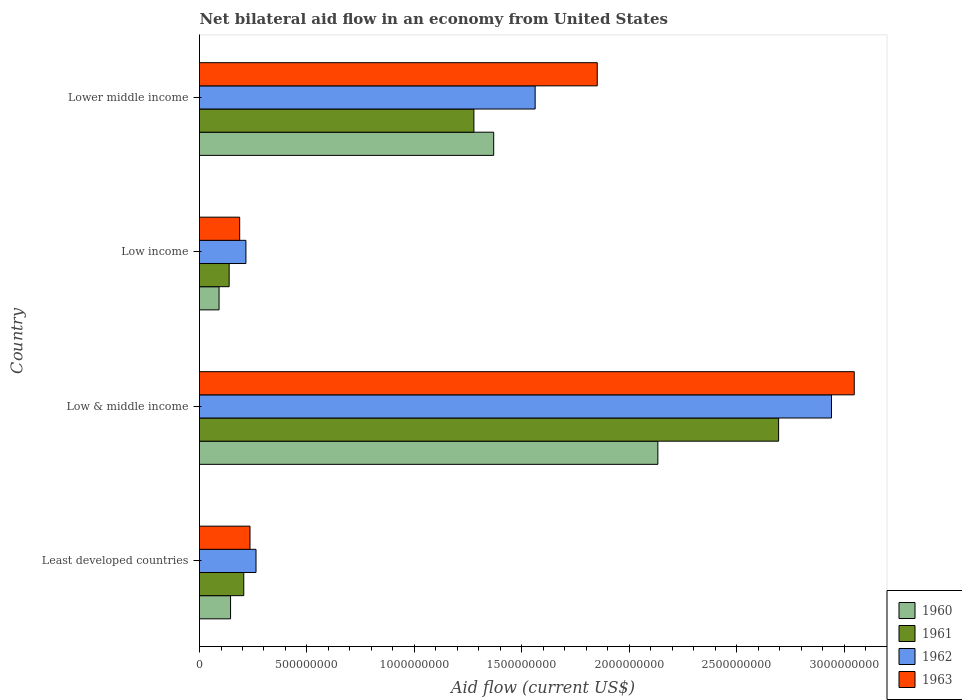How many different coloured bars are there?
Your response must be concise. 4. How many groups of bars are there?
Offer a terse response. 4. Are the number of bars per tick equal to the number of legend labels?
Provide a succinct answer. Yes. How many bars are there on the 2nd tick from the top?
Give a very brief answer. 4. How many bars are there on the 1st tick from the bottom?
Your answer should be compact. 4. What is the label of the 1st group of bars from the top?
Give a very brief answer. Lower middle income. In how many cases, is the number of bars for a given country not equal to the number of legend labels?
Offer a very short reply. 0. What is the net bilateral aid flow in 1960 in Low & middle income?
Provide a succinct answer. 2.13e+09. Across all countries, what is the maximum net bilateral aid flow in 1960?
Give a very brief answer. 2.13e+09. Across all countries, what is the minimum net bilateral aid flow in 1960?
Offer a very short reply. 9.10e+07. What is the total net bilateral aid flow in 1962 in the graph?
Your answer should be compact. 4.98e+09. What is the difference between the net bilateral aid flow in 1963 in Least developed countries and that in Lower middle income?
Give a very brief answer. -1.62e+09. What is the difference between the net bilateral aid flow in 1961 in Lower middle income and the net bilateral aid flow in 1960 in Low income?
Keep it short and to the point. 1.19e+09. What is the average net bilateral aid flow in 1960 per country?
Provide a succinct answer. 9.34e+08. What is the difference between the net bilateral aid flow in 1961 and net bilateral aid flow in 1960 in Least developed countries?
Give a very brief answer. 6.15e+07. What is the ratio of the net bilateral aid flow in 1961 in Least developed countries to that in Low & middle income?
Give a very brief answer. 0.08. What is the difference between the highest and the second highest net bilateral aid flow in 1961?
Provide a short and direct response. 1.42e+09. What is the difference between the highest and the lowest net bilateral aid flow in 1961?
Your answer should be compact. 2.56e+09. Is the sum of the net bilateral aid flow in 1962 in Least developed countries and Low & middle income greater than the maximum net bilateral aid flow in 1961 across all countries?
Offer a terse response. Yes. What does the 1st bar from the top in Low & middle income represents?
Offer a terse response. 1963. What does the 4th bar from the bottom in Lower middle income represents?
Keep it short and to the point. 1963. How many countries are there in the graph?
Offer a terse response. 4. Does the graph contain any zero values?
Give a very brief answer. No. Does the graph contain grids?
Offer a terse response. No. Where does the legend appear in the graph?
Keep it short and to the point. Bottom right. What is the title of the graph?
Your answer should be compact. Net bilateral aid flow in an economy from United States. Does "1976" appear as one of the legend labels in the graph?
Your response must be concise. No. What is the label or title of the Y-axis?
Offer a very short reply. Country. What is the Aid flow (current US$) of 1960 in Least developed countries?
Provide a succinct answer. 1.45e+08. What is the Aid flow (current US$) of 1961 in Least developed countries?
Offer a terse response. 2.06e+08. What is the Aid flow (current US$) of 1962 in Least developed countries?
Provide a succinct answer. 2.63e+08. What is the Aid flow (current US$) in 1963 in Least developed countries?
Provide a short and direct response. 2.35e+08. What is the Aid flow (current US$) in 1960 in Low & middle income?
Provide a succinct answer. 2.13e+09. What is the Aid flow (current US$) in 1961 in Low & middle income?
Offer a very short reply. 2.70e+09. What is the Aid flow (current US$) of 1962 in Low & middle income?
Make the answer very short. 2.94e+09. What is the Aid flow (current US$) of 1963 in Low & middle income?
Make the answer very short. 3.05e+09. What is the Aid flow (current US$) of 1960 in Low income?
Keep it short and to the point. 9.10e+07. What is the Aid flow (current US$) in 1961 in Low income?
Your answer should be compact. 1.38e+08. What is the Aid flow (current US$) of 1962 in Low income?
Ensure brevity in your answer.  2.16e+08. What is the Aid flow (current US$) of 1963 in Low income?
Provide a short and direct response. 1.87e+08. What is the Aid flow (current US$) in 1960 in Lower middle income?
Offer a terse response. 1.37e+09. What is the Aid flow (current US$) in 1961 in Lower middle income?
Give a very brief answer. 1.28e+09. What is the Aid flow (current US$) of 1962 in Lower middle income?
Your answer should be compact. 1.56e+09. What is the Aid flow (current US$) in 1963 in Lower middle income?
Provide a succinct answer. 1.85e+09. Across all countries, what is the maximum Aid flow (current US$) of 1960?
Your response must be concise. 2.13e+09. Across all countries, what is the maximum Aid flow (current US$) of 1961?
Offer a very short reply. 2.70e+09. Across all countries, what is the maximum Aid flow (current US$) in 1962?
Provide a succinct answer. 2.94e+09. Across all countries, what is the maximum Aid flow (current US$) in 1963?
Your answer should be very brief. 3.05e+09. Across all countries, what is the minimum Aid flow (current US$) of 1960?
Keep it short and to the point. 9.10e+07. Across all countries, what is the minimum Aid flow (current US$) of 1961?
Keep it short and to the point. 1.38e+08. Across all countries, what is the minimum Aid flow (current US$) in 1962?
Give a very brief answer. 2.16e+08. Across all countries, what is the minimum Aid flow (current US$) in 1963?
Your answer should be compact. 1.87e+08. What is the total Aid flow (current US$) in 1960 in the graph?
Provide a succinct answer. 3.74e+09. What is the total Aid flow (current US$) of 1961 in the graph?
Your answer should be compact. 4.32e+09. What is the total Aid flow (current US$) of 1962 in the graph?
Provide a succinct answer. 4.98e+09. What is the total Aid flow (current US$) in 1963 in the graph?
Your answer should be very brief. 5.32e+09. What is the difference between the Aid flow (current US$) of 1960 in Least developed countries and that in Low & middle income?
Your answer should be very brief. -1.99e+09. What is the difference between the Aid flow (current US$) in 1961 in Least developed countries and that in Low & middle income?
Offer a terse response. -2.49e+09. What is the difference between the Aid flow (current US$) in 1962 in Least developed countries and that in Low & middle income?
Offer a very short reply. -2.68e+09. What is the difference between the Aid flow (current US$) of 1963 in Least developed countries and that in Low & middle income?
Provide a succinct answer. -2.81e+09. What is the difference between the Aid flow (current US$) in 1960 in Least developed countries and that in Low income?
Your answer should be compact. 5.35e+07. What is the difference between the Aid flow (current US$) of 1961 in Least developed countries and that in Low income?
Your answer should be very brief. 6.80e+07. What is the difference between the Aid flow (current US$) in 1962 in Least developed countries and that in Low income?
Your answer should be compact. 4.70e+07. What is the difference between the Aid flow (current US$) of 1963 in Least developed countries and that in Low income?
Provide a short and direct response. 4.80e+07. What is the difference between the Aid flow (current US$) of 1960 in Least developed countries and that in Lower middle income?
Ensure brevity in your answer.  -1.22e+09. What is the difference between the Aid flow (current US$) in 1961 in Least developed countries and that in Lower middle income?
Offer a terse response. -1.07e+09. What is the difference between the Aid flow (current US$) in 1962 in Least developed countries and that in Lower middle income?
Your answer should be very brief. -1.30e+09. What is the difference between the Aid flow (current US$) in 1963 in Least developed countries and that in Lower middle income?
Give a very brief answer. -1.62e+09. What is the difference between the Aid flow (current US$) in 1960 in Low & middle income and that in Low income?
Ensure brevity in your answer.  2.04e+09. What is the difference between the Aid flow (current US$) in 1961 in Low & middle income and that in Low income?
Your answer should be very brief. 2.56e+09. What is the difference between the Aid flow (current US$) of 1962 in Low & middle income and that in Low income?
Your answer should be very brief. 2.72e+09. What is the difference between the Aid flow (current US$) in 1963 in Low & middle income and that in Low income?
Offer a very short reply. 2.86e+09. What is the difference between the Aid flow (current US$) in 1960 in Low & middle income and that in Lower middle income?
Your answer should be very brief. 7.64e+08. What is the difference between the Aid flow (current US$) in 1961 in Low & middle income and that in Lower middle income?
Your response must be concise. 1.42e+09. What is the difference between the Aid flow (current US$) in 1962 in Low & middle income and that in Lower middle income?
Offer a terse response. 1.38e+09. What is the difference between the Aid flow (current US$) in 1963 in Low & middle income and that in Lower middle income?
Keep it short and to the point. 1.20e+09. What is the difference between the Aid flow (current US$) of 1960 in Low income and that in Lower middle income?
Offer a very short reply. -1.28e+09. What is the difference between the Aid flow (current US$) in 1961 in Low income and that in Lower middle income?
Offer a very short reply. -1.14e+09. What is the difference between the Aid flow (current US$) in 1962 in Low income and that in Lower middle income?
Offer a very short reply. -1.35e+09. What is the difference between the Aid flow (current US$) in 1963 in Low income and that in Lower middle income?
Provide a short and direct response. -1.66e+09. What is the difference between the Aid flow (current US$) in 1960 in Least developed countries and the Aid flow (current US$) in 1961 in Low & middle income?
Offer a very short reply. -2.55e+09. What is the difference between the Aid flow (current US$) of 1960 in Least developed countries and the Aid flow (current US$) of 1962 in Low & middle income?
Your answer should be compact. -2.80e+09. What is the difference between the Aid flow (current US$) in 1960 in Least developed countries and the Aid flow (current US$) in 1963 in Low & middle income?
Keep it short and to the point. -2.90e+09. What is the difference between the Aid flow (current US$) in 1961 in Least developed countries and the Aid flow (current US$) in 1962 in Low & middle income?
Your answer should be very brief. -2.74e+09. What is the difference between the Aid flow (current US$) of 1961 in Least developed countries and the Aid flow (current US$) of 1963 in Low & middle income?
Your response must be concise. -2.84e+09. What is the difference between the Aid flow (current US$) in 1962 in Least developed countries and the Aid flow (current US$) in 1963 in Low & middle income?
Keep it short and to the point. -2.78e+09. What is the difference between the Aid flow (current US$) in 1960 in Least developed countries and the Aid flow (current US$) in 1961 in Low income?
Provide a succinct answer. 6.52e+06. What is the difference between the Aid flow (current US$) of 1960 in Least developed countries and the Aid flow (current US$) of 1962 in Low income?
Offer a very short reply. -7.15e+07. What is the difference between the Aid flow (current US$) of 1960 in Least developed countries and the Aid flow (current US$) of 1963 in Low income?
Provide a short and direct response. -4.25e+07. What is the difference between the Aid flow (current US$) of 1961 in Least developed countries and the Aid flow (current US$) of 1962 in Low income?
Your response must be concise. -1.00e+07. What is the difference between the Aid flow (current US$) of 1961 in Least developed countries and the Aid flow (current US$) of 1963 in Low income?
Make the answer very short. 1.90e+07. What is the difference between the Aid flow (current US$) in 1962 in Least developed countries and the Aid flow (current US$) in 1963 in Low income?
Your answer should be very brief. 7.60e+07. What is the difference between the Aid flow (current US$) of 1960 in Least developed countries and the Aid flow (current US$) of 1961 in Lower middle income?
Offer a terse response. -1.13e+09. What is the difference between the Aid flow (current US$) in 1960 in Least developed countries and the Aid flow (current US$) in 1962 in Lower middle income?
Give a very brief answer. -1.42e+09. What is the difference between the Aid flow (current US$) in 1960 in Least developed countries and the Aid flow (current US$) in 1963 in Lower middle income?
Give a very brief answer. -1.71e+09. What is the difference between the Aid flow (current US$) of 1961 in Least developed countries and the Aid flow (current US$) of 1962 in Lower middle income?
Give a very brief answer. -1.36e+09. What is the difference between the Aid flow (current US$) of 1961 in Least developed countries and the Aid flow (current US$) of 1963 in Lower middle income?
Ensure brevity in your answer.  -1.64e+09. What is the difference between the Aid flow (current US$) in 1962 in Least developed countries and the Aid flow (current US$) in 1963 in Lower middle income?
Offer a very short reply. -1.59e+09. What is the difference between the Aid flow (current US$) of 1960 in Low & middle income and the Aid flow (current US$) of 1961 in Low income?
Provide a succinct answer. 2.00e+09. What is the difference between the Aid flow (current US$) of 1960 in Low & middle income and the Aid flow (current US$) of 1962 in Low income?
Ensure brevity in your answer.  1.92e+09. What is the difference between the Aid flow (current US$) of 1960 in Low & middle income and the Aid flow (current US$) of 1963 in Low income?
Ensure brevity in your answer.  1.95e+09. What is the difference between the Aid flow (current US$) in 1961 in Low & middle income and the Aid flow (current US$) in 1962 in Low income?
Make the answer very short. 2.48e+09. What is the difference between the Aid flow (current US$) in 1961 in Low & middle income and the Aid flow (current US$) in 1963 in Low income?
Provide a succinct answer. 2.51e+09. What is the difference between the Aid flow (current US$) of 1962 in Low & middle income and the Aid flow (current US$) of 1963 in Low income?
Give a very brief answer. 2.75e+09. What is the difference between the Aid flow (current US$) of 1960 in Low & middle income and the Aid flow (current US$) of 1961 in Lower middle income?
Make the answer very short. 8.56e+08. What is the difference between the Aid flow (current US$) in 1960 in Low & middle income and the Aid flow (current US$) in 1962 in Lower middle income?
Your response must be concise. 5.71e+08. What is the difference between the Aid flow (current US$) of 1960 in Low & middle income and the Aid flow (current US$) of 1963 in Lower middle income?
Your response must be concise. 2.82e+08. What is the difference between the Aid flow (current US$) of 1961 in Low & middle income and the Aid flow (current US$) of 1962 in Lower middle income?
Provide a succinct answer. 1.13e+09. What is the difference between the Aid flow (current US$) of 1961 in Low & middle income and the Aid flow (current US$) of 1963 in Lower middle income?
Offer a terse response. 8.44e+08. What is the difference between the Aid flow (current US$) in 1962 in Low & middle income and the Aid flow (current US$) in 1963 in Lower middle income?
Your answer should be very brief. 1.09e+09. What is the difference between the Aid flow (current US$) in 1960 in Low income and the Aid flow (current US$) in 1961 in Lower middle income?
Provide a short and direct response. -1.19e+09. What is the difference between the Aid flow (current US$) in 1960 in Low income and the Aid flow (current US$) in 1962 in Lower middle income?
Your response must be concise. -1.47e+09. What is the difference between the Aid flow (current US$) of 1960 in Low income and the Aid flow (current US$) of 1963 in Lower middle income?
Make the answer very short. -1.76e+09. What is the difference between the Aid flow (current US$) of 1961 in Low income and the Aid flow (current US$) of 1962 in Lower middle income?
Provide a succinct answer. -1.42e+09. What is the difference between the Aid flow (current US$) of 1961 in Low income and the Aid flow (current US$) of 1963 in Lower middle income?
Your response must be concise. -1.71e+09. What is the difference between the Aid flow (current US$) in 1962 in Low income and the Aid flow (current US$) in 1963 in Lower middle income?
Make the answer very short. -1.64e+09. What is the average Aid flow (current US$) of 1960 per country?
Provide a succinct answer. 9.34e+08. What is the average Aid flow (current US$) of 1961 per country?
Make the answer very short. 1.08e+09. What is the average Aid flow (current US$) in 1962 per country?
Your answer should be compact. 1.25e+09. What is the average Aid flow (current US$) in 1963 per country?
Your answer should be very brief. 1.33e+09. What is the difference between the Aid flow (current US$) of 1960 and Aid flow (current US$) of 1961 in Least developed countries?
Make the answer very short. -6.15e+07. What is the difference between the Aid flow (current US$) of 1960 and Aid flow (current US$) of 1962 in Least developed countries?
Provide a short and direct response. -1.18e+08. What is the difference between the Aid flow (current US$) of 1960 and Aid flow (current US$) of 1963 in Least developed countries?
Your response must be concise. -9.05e+07. What is the difference between the Aid flow (current US$) of 1961 and Aid flow (current US$) of 1962 in Least developed countries?
Give a very brief answer. -5.70e+07. What is the difference between the Aid flow (current US$) in 1961 and Aid flow (current US$) in 1963 in Least developed countries?
Give a very brief answer. -2.90e+07. What is the difference between the Aid flow (current US$) of 1962 and Aid flow (current US$) of 1963 in Least developed countries?
Provide a succinct answer. 2.80e+07. What is the difference between the Aid flow (current US$) in 1960 and Aid flow (current US$) in 1961 in Low & middle income?
Your answer should be very brief. -5.62e+08. What is the difference between the Aid flow (current US$) of 1960 and Aid flow (current US$) of 1962 in Low & middle income?
Your answer should be very brief. -8.08e+08. What is the difference between the Aid flow (current US$) of 1960 and Aid flow (current US$) of 1963 in Low & middle income?
Offer a very short reply. -9.14e+08. What is the difference between the Aid flow (current US$) of 1961 and Aid flow (current US$) of 1962 in Low & middle income?
Keep it short and to the point. -2.46e+08. What is the difference between the Aid flow (current US$) of 1961 and Aid flow (current US$) of 1963 in Low & middle income?
Your answer should be compact. -3.52e+08. What is the difference between the Aid flow (current US$) in 1962 and Aid flow (current US$) in 1963 in Low & middle income?
Keep it short and to the point. -1.06e+08. What is the difference between the Aid flow (current US$) of 1960 and Aid flow (current US$) of 1961 in Low income?
Your response must be concise. -4.70e+07. What is the difference between the Aid flow (current US$) of 1960 and Aid flow (current US$) of 1962 in Low income?
Make the answer very short. -1.25e+08. What is the difference between the Aid flow (current US$) in 1960 and Aid flow (current US$) in 1963 in Low income?
Offer a terse response. -9.60e+07. What is the difference between the Aid flow (current US$) of 1961 and Aid flow (current US$) of 1962 in Low income?
Provide a succinct answer. -7.80e+07. What is the difference between the Aid flow (current US$) in 1961 and Aid flow (current US$) in 1963 in Low income?
Make the answer very short. -4.90e+07. What is the difference between the Aid flow (current US$) in 1962 and Aid flow (current US$) in 1963 in Low income?
Your response must be concise. 2.90e+07. What is the difference between the Aid flow (current US$) of 1960 and Aid flow (current US$) of 1961 in Lower middle income?
Your answer should be compact. 9.20e+07. What is the difference between the Aid flow (current US$) of 1960 and Aid flow (current US$) of 1962 in Lower middle income?
Offer a very short reply. -1.93e+08. What is the difference between the Aid flow (current US$) of 1960 and Aid flow (current US$) of 1963 in Lower middle income?
Ensure brevity in your answer.  -4.82e+08. What is the difference between the Aid flow (current US$) of 1961 and Aid flow (current US$) of 1962 in Lower middle income?
Keep it short and to the point. -2.85e+08. What is the difference between the Aid flow (current US$) in 1961 and Aid flow (current US$) in 1963 in Lower middle income?
Your response must be concise. -5.74e+08. What is the difference between the Aid flow (current US$) of 1962 and Aid flow (current US$) of 1963 in Lower middle income?
Make the answer very short. -2.89e+08. What is the ratio of the Aid flow (current US$) of 1960 in Least developed countries to that in Low & middle income?
Ensure brevity in your answer.  0.07. What is the ratio of the Aid flow (current US$) of 1961 in Least developed countries to that in Low & middle income?
Keep it short and to the point. 0.08. What is the ratio of the Aid flow (current US$) in 1962 in Least developed countries to that in Low & middle income?
Offer a very short reply. 0.09. What is the ratio of the Aid flow (current US$) of 1963 in Least developed countries to that in Low & middle income?
Offer a terse response. 0.08. What is the ratio of the Aid flow (current US$) in 1960 in Least developed countries to that in Low income?
Your response must be concise. 1.59. What is the ratio of the Aid flow (current US$) of 1961 in Least developed countries to that in Low income?
Your response must be concise. 1.49. What is the ratio of the Aid flow (current US$) of 1962 in Least developed countries to that in Low income?
Give a very brief answer. 1.22. What is the ratio of the Aid flow (current US$) in 1963 in Least developed countries to that in Low income?
Offer a very short reply. 1.26. What is the ratio of the Aid flow (current US$) in 1960 in Least developed countries to that in Lower middle income?
Your answer should be very brief. 0.11. What is the ratio of the Aid flow (current US$) in 1961 in Least developed countries to that in Lower middle income?
Offer a very short reply. 0.16. What is the ratio of the Aid flow (current US$) in 1962 in Least developed countries to that in Lower middle income?
Ensure brevity in your answer.  0.17. What is the ratio of the Aid flow (current US$) of 1963 in Least developed countries to that in Lower middle income?
Keep it short and to the point. 0.13. What is the ratio of the Aid flow (current US$) of 1960 in Low & middle income to that in Low income?
Your response must be concise. 23.44. What is the ratio of the Aid flow (current US$) in 1961 in Low & middle income to that in Low income?
Provide a succinct answer. 19.53. What is the ratio of the Aid flow (current US$) in 1962 in Low & middle income to that in Low income?
Provide a succinct answer. 13.62. What is the ratio of the Aid flow (current US$) in 1963 in Low & middle income to that in Low income?
Your response must be concise. 16.29. What is the ratio of the Aid flow (current US$) in 1960 in Low & middle income to that in Lower middle income?
Your answer should be very brief. 1.56. What is the ratio of the Aid flow (current US$) of 1961 in Low & middle income to that in Lower middle income?
Your answer should be very brief. 2.11. What is the ratio of the Aid flow (current US$) of 1962 in Low & middle income to that in Lower middle income?
Your answer should be compact. 1.88. What is the ratio of the Aid flow (current US$) of 1963 in Low & middle income to that in Lower middle income?
Keep it short and to the point. 1.65. What is the ratio of the Aid flow (current US$) of 1960 in Low income to that in Lower middle income?
Offer a terse response. 0.07. What is the ratio of the Aid flow (current US$) of 1961 in Low income to that in Lower middle income?
Offer a terse response. 0.11. What is the ratio of the Aid flow (current US$) of 1962 in Low income to that in Lower middle income?
Offer a very short reply. 0.14. What is the ratio of the Aid flow (current US$) in 1963 in Low income to that in Lower middle income?
Provide a short and direct response. 0.1. What is the difference between the highest and the second highest Aid flow (current US$) in 1960?
Provide a succinct answer. 7.64e+08. What is the difference between the highest and the second highest Aid flow (current US$) in 1961?
Give a very brief answer. 1.42e+09. What is the difference between the highest and the second highest Aid flow (current US$) in 1962?
Provide a succinct answer. 1.38e+09. What is the difference between the highest and the second highest Aid flow (current US$) in 1963?
Provide a short and direct response. 1.20e+09. What is the difference between the highest and the lowest Aid flow (current US$) in 1960?
Your answer should be very brief. 2.04e+09. What is the difference between the highest and the lowest Aid flow (current US$) of 1961?
Your answer should be very brief. 2.56e+09. What is the difference between the highest and the lowest Aid flow (current US$) in 1962?
Ensure brevity in your answer.  2.72e+09. What is the difference between the highest and the lowest Aid flow (current US$) of 1963?
Offer a very short reply. 2.86e+09. 